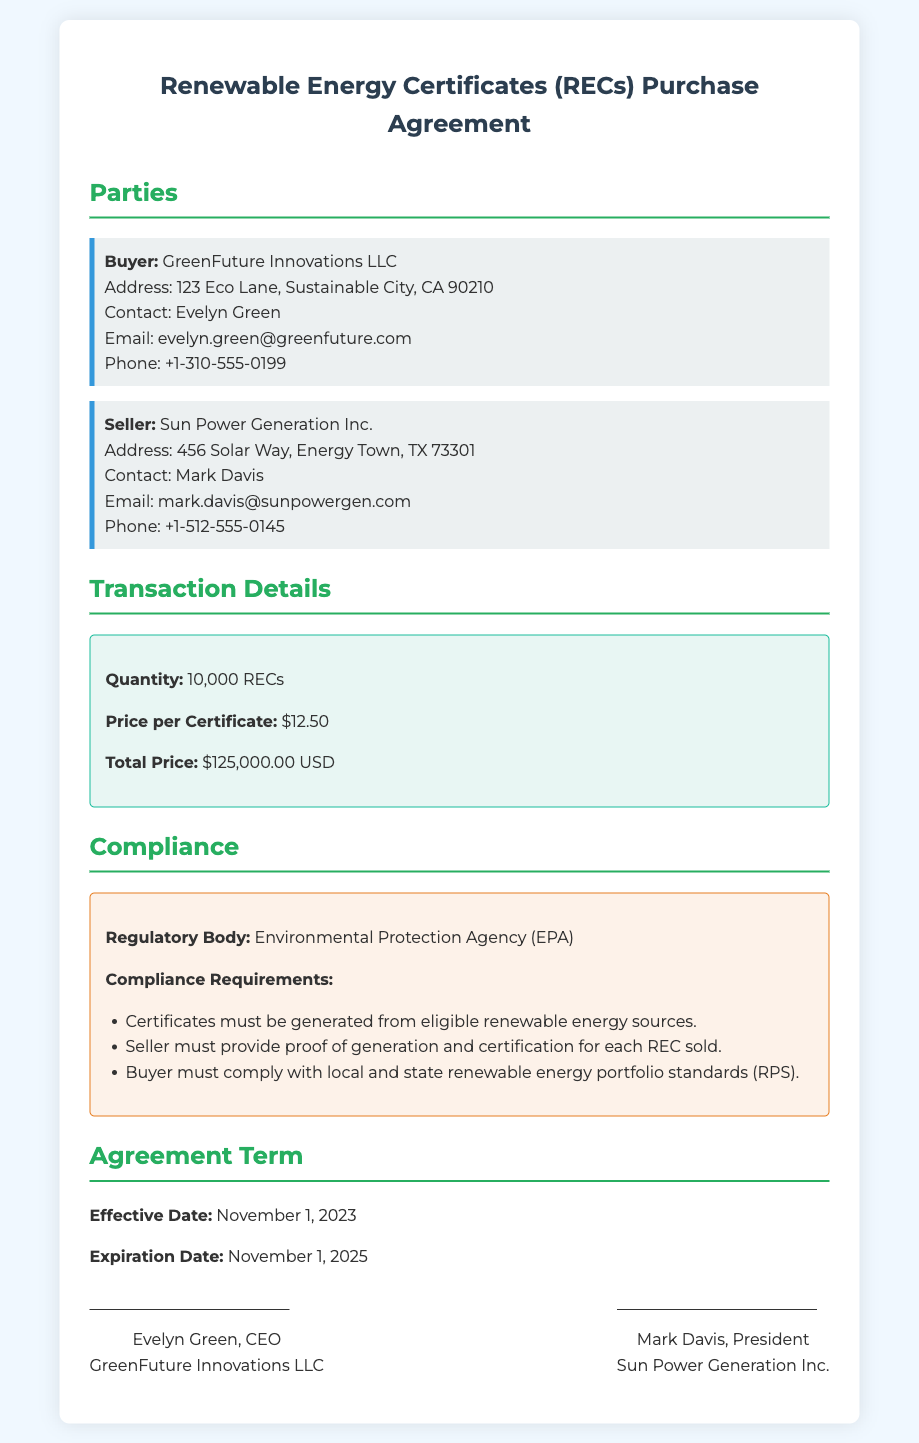what is the quantity purchased? The quantity purchased is mentioned directly in the transaction details section of the document.
Answer: 10,000 RECs what is the price per certificate? The price per certificate is indicated in the transaction details section of the document.
Answer: $12.50 what is the total price? The total price is calculated based on the quantity and price per certificate, as stated in the document.
Answer: $125,000.00 USD who is the buyer? The buyer's details are provided at the beginning of the document under the parties section.
Answer: GreenFuture Innovations LLC what is the effective date of the agreement? The effective date is listed clearly under the agreement term section of the document.
Answer: November 1, 2023 who must provide proof of generation for each REC sold? This requirement is specified in the compliance section of the document, addressing the seller's responsibilities.
Answer: Seller what regulatory body oversees compliance? The regulatory body is mentioned in the compliance section of the document.
Answer: Environmental Protection Agency (EPA) what is the expiration date of the agreement? The expiration date can be found under the agreement term section of the document.
Answer: November 1, 2025 what is the name of the seller's president? The name of the seller's president is mentioned in the signatures section of the document.
Answer: Mark Davis 